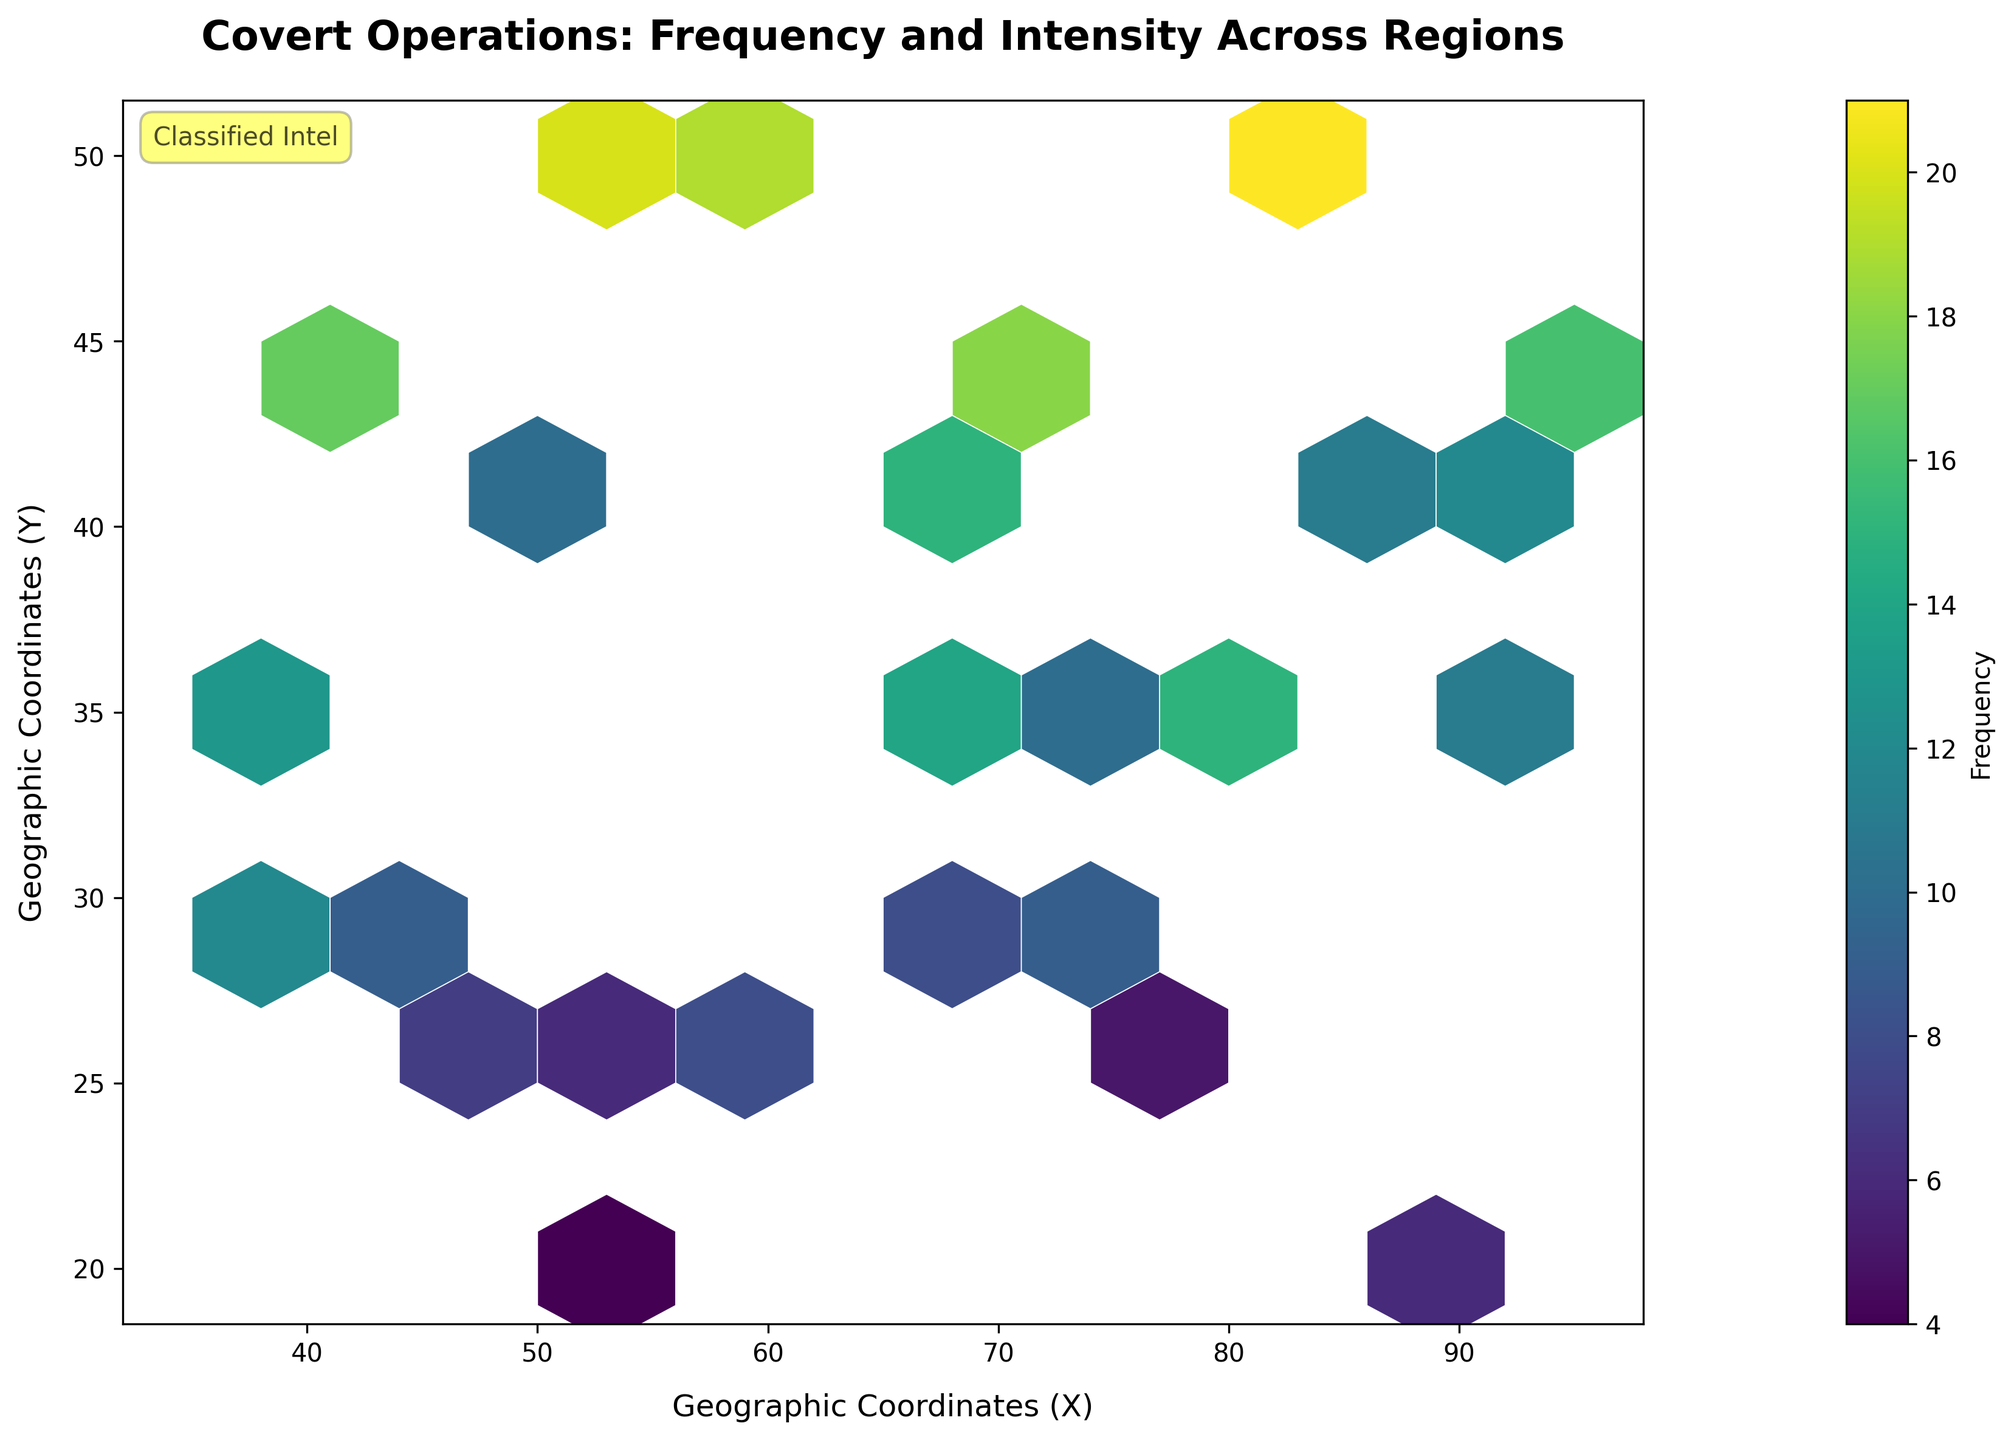What is the title of the figure? The title is typically found at the top of the plot, which helps in understanding the context and subject of the figure.
Answer: Covert Operations: Frequency and Intensity Across Regions What do the X and Y axes represent in this plot? The titles for the axes are labeled to indicate what each axis represents.
Answer: Geographic Coordinates (X) and Geographic Coordinates (Y) What does the color represent in this hexbin plot? The color in a hexbin plot commonly indicates the magnitude or frequency of the data points within each bin. Here, the color bar and its label provide this information.
Answer: Frequency Which area (X, Y) has the highest frequency represented on the plot? By observing the color gradient and identifying the bin with the most intense color, you can find the area with the highest frequency.
Answer: (55, 50) Compare the frequency between the coordinates (50, 40) and (40, 45). Which one has a higher frequency? First, locate both coordinates on the plot. Then, compare the color intensity or use the color bar to determine which one has a higher frequency.
Answer: (40, 45) At which coordinate is the frequency exactly 20? Locate the bin that matches the frequency value of 20 using the color bar or color gradient in the plot.
Answer: (55, 50) How many bins have a frequency of 18 or higher? Identify the bins with colors that correspond to a frequency of 18 or higher according to the color bar and count them.
Answer: 4 What geographic region has the lowest frequency recorded on this plot? Find the bin with the least intense color, which corresponds to the lowest frequency according to the color bar.
Answer: (50, 20) What is the average frequency for bins along the Y-coordinate of 35? Locate and sum the frequencies of all bins at Y=35, then divide by the number of such bins to find the average. Bins are (80, 35), (65, 35), (55, 35), (95, 35), (75, 35). Frequencies are 15, 14, 6, 11, 10: (15 + 14 + 6 + 11 + 10) / 5 = 56 / 5 = 11.2.
Answer: 11.2 